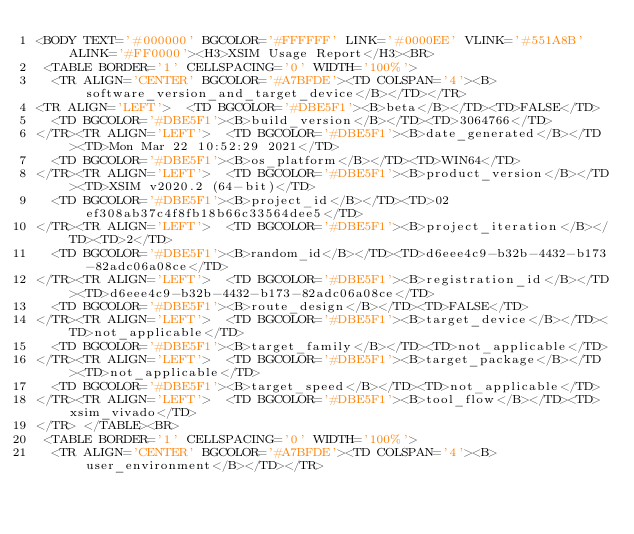Convert code to text. <code><loc_0><loc_0><loc_500><loc_500><_HTML_><BODY TEXT='#000000' BGCOLOR='#FFFFFF' LINK='#0000EE' VLINK='#551A8B' ALINK='#FF0000'><H3>XSIM Usage Report</H3><BR>
 <TABLE BORDER='1' CELLSPACING='0' WIDTH='100%'>
  <TR ALIGN='CENTER' BGCOLOR='#A7BFDE'><TD COLSPAN='4'><B>software_version_and_target_device</B></TD></TR>
<TR ALIGN='LEFT'>  <TD BGCOLOR='#DBE5F1'><B>beta</B></TD><TD>FALSE</TD>
  <TD BGCOLOR='#DBE5F1'><B>build_version</B></TD><TD>3064766</TD>
</TR><TR ALIGN='LEFT'>  <TD BGCOLOR='#DBE5F1'><B>date_generated</B></TD><TD>Mon Mar 22 10:52:29 2021</TD>
  <TD BGCOLOR='#DBE5F1'><B>os_platform</B></TD><TD>WIN64</TD>
</TR><TR ALIGN='LEFT'>  <TD BGCOLOR='#DBE5F1'><B>product_version</B></TD><TD>XSIM v2020.2 (64-bit)</TD>
  <TD BGCOLOR='#DBE5F1'><B>project_id</B></TD><TD>02ef308ab37c4f8fb18b66c33564dee5</TD>
</TR><TR ALIGN='LEFT'>  <TD BGCOLOR='#DBE5F1'><B>project_iteration</B></TD><TD>2</TD>
  <TD BGCOLOR='#DBE5F1'><B>random_id</B></TD><TD>d6eee4c9-b32b-4432-b173-82adc06a08ce</TD>
</TR><TR ALIGN='LEFT'>  <TD BGCOLOR='#DBE5F1'><B>registration_id</B></TD><TD>d6eee4c9-b32b-4432-b173-82adc06a08ce</TD>
  <TD BGCOLOR='#DBE5F1'><B>route_design</B></TD><TD>FALSE</TD>
</TR><TR ALIGN='LEFT'>  <TD BGCOLOR='#DBE5F1'><B>target_device</B></TD><TD>not_applicable</TD>
  <TD BGCOLOR='#DBE5F1'><B>target_family</B></TD><TD>not_applicable</TD>
</TR><TR ALIGN='LEFT'>  <TD BGCOLOR='#DBE5F1'><B>target_package</B></TD><TD>not_applicable</TD>
  <TD BGCOLOR='#DBE5F1'><B>target_speed</B></TD><TD>not_applicable</TD>
</TR><TR ALIGN='LEFT'>  <TD BGCOLOR='#DBE5F1'><B>tool_flow</B></TD><TD>xsim_vivado</TD>
</TR> </TABLE><BR>
 <TABLE BORDER='1' CELLSPACING='0' WIDTH='100%'>
  <TR ALIGN='CENTER' BGCOLOR='#A7BFDE'><TD COLSPAN='4'><B>user_environment</B></TD></TR></code> 